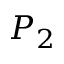Convert formula to latex. <formula><loc_0><loc_0><loc_500><loc_500>P _ { 2 }</formula> 